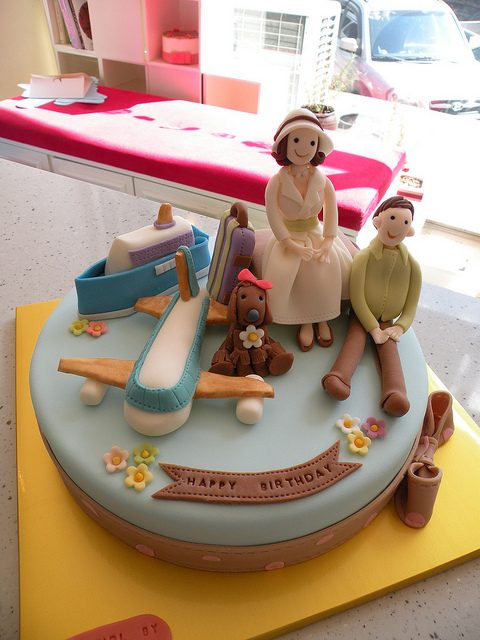<image>What type of flowers are on the cake? I am not sure about the type of flowers on the cake. It can be daisy or lilies or none. What season is depicted on the cake? It is ambiguous what season is depicted on the cake. It can be either spring or summer. What season is depicted on the cake? It is ambiguous what season is depicted on the cake. It can be seen 'spring', 'summer' or 'birthday'. What type of flowers are on the cake? I am not sure what type of flowers are on the cake. It can be seen 'daisy', 'fondant', 'lilies', 'daisies', 'decoration flowers', 'icing flowers', or 'sweet pea'. 